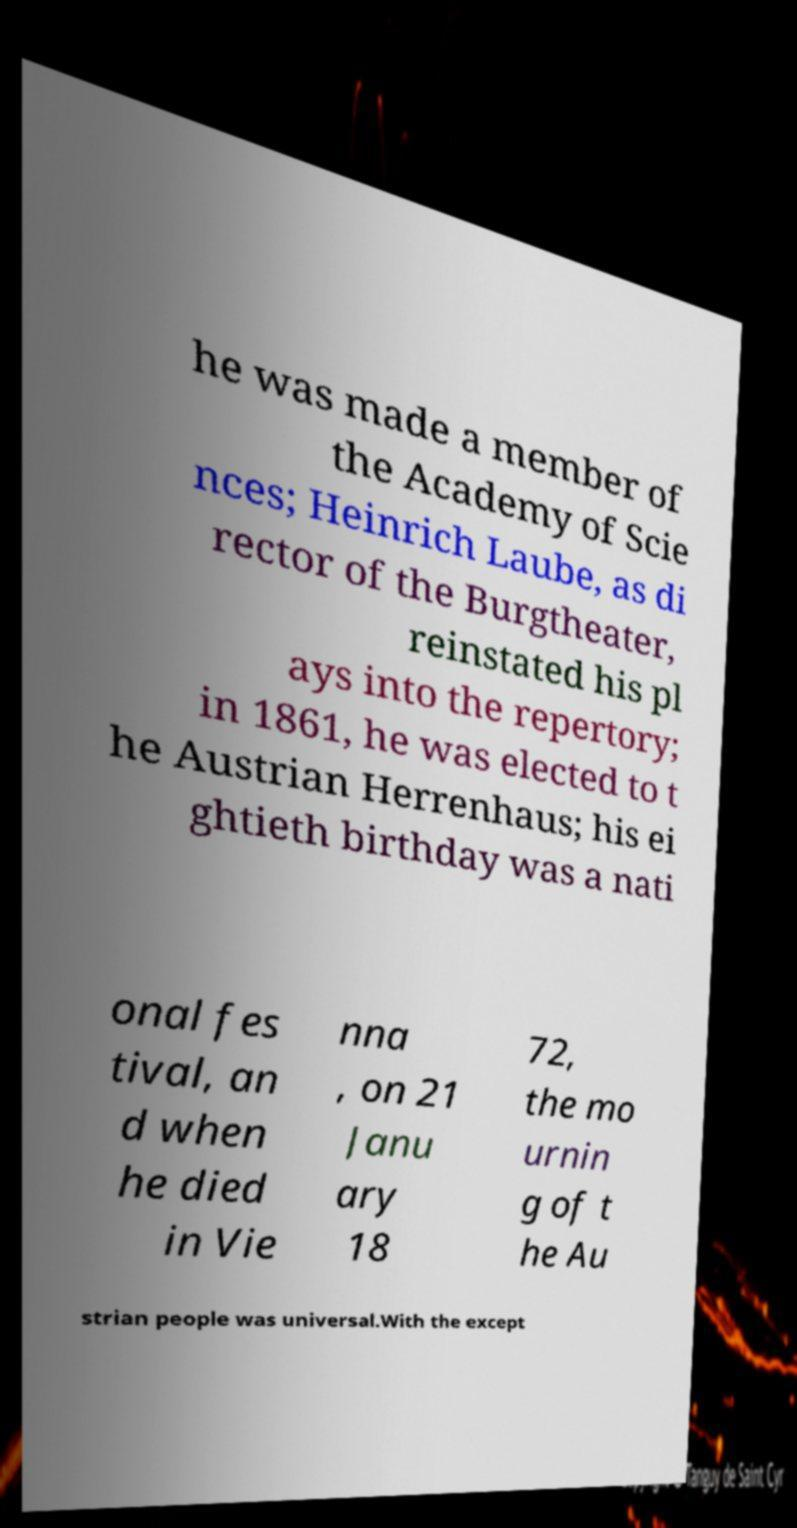Can you accurately transcribe the text from the provided image for me? he was made a member of the Academy of Scie nces; Heinrich Laube, as di rector of the Burgtheater, reinstated his pl ays into the repertory; in 1861, he was elected to t he Austrian Herrenhaus; his ei ghtieth birthday was a nati onal fes tival, an d when he died in Vie nna , on 21 Janu ary 18 72, the mo urnin g of t he Au strian people was universal.With the except 